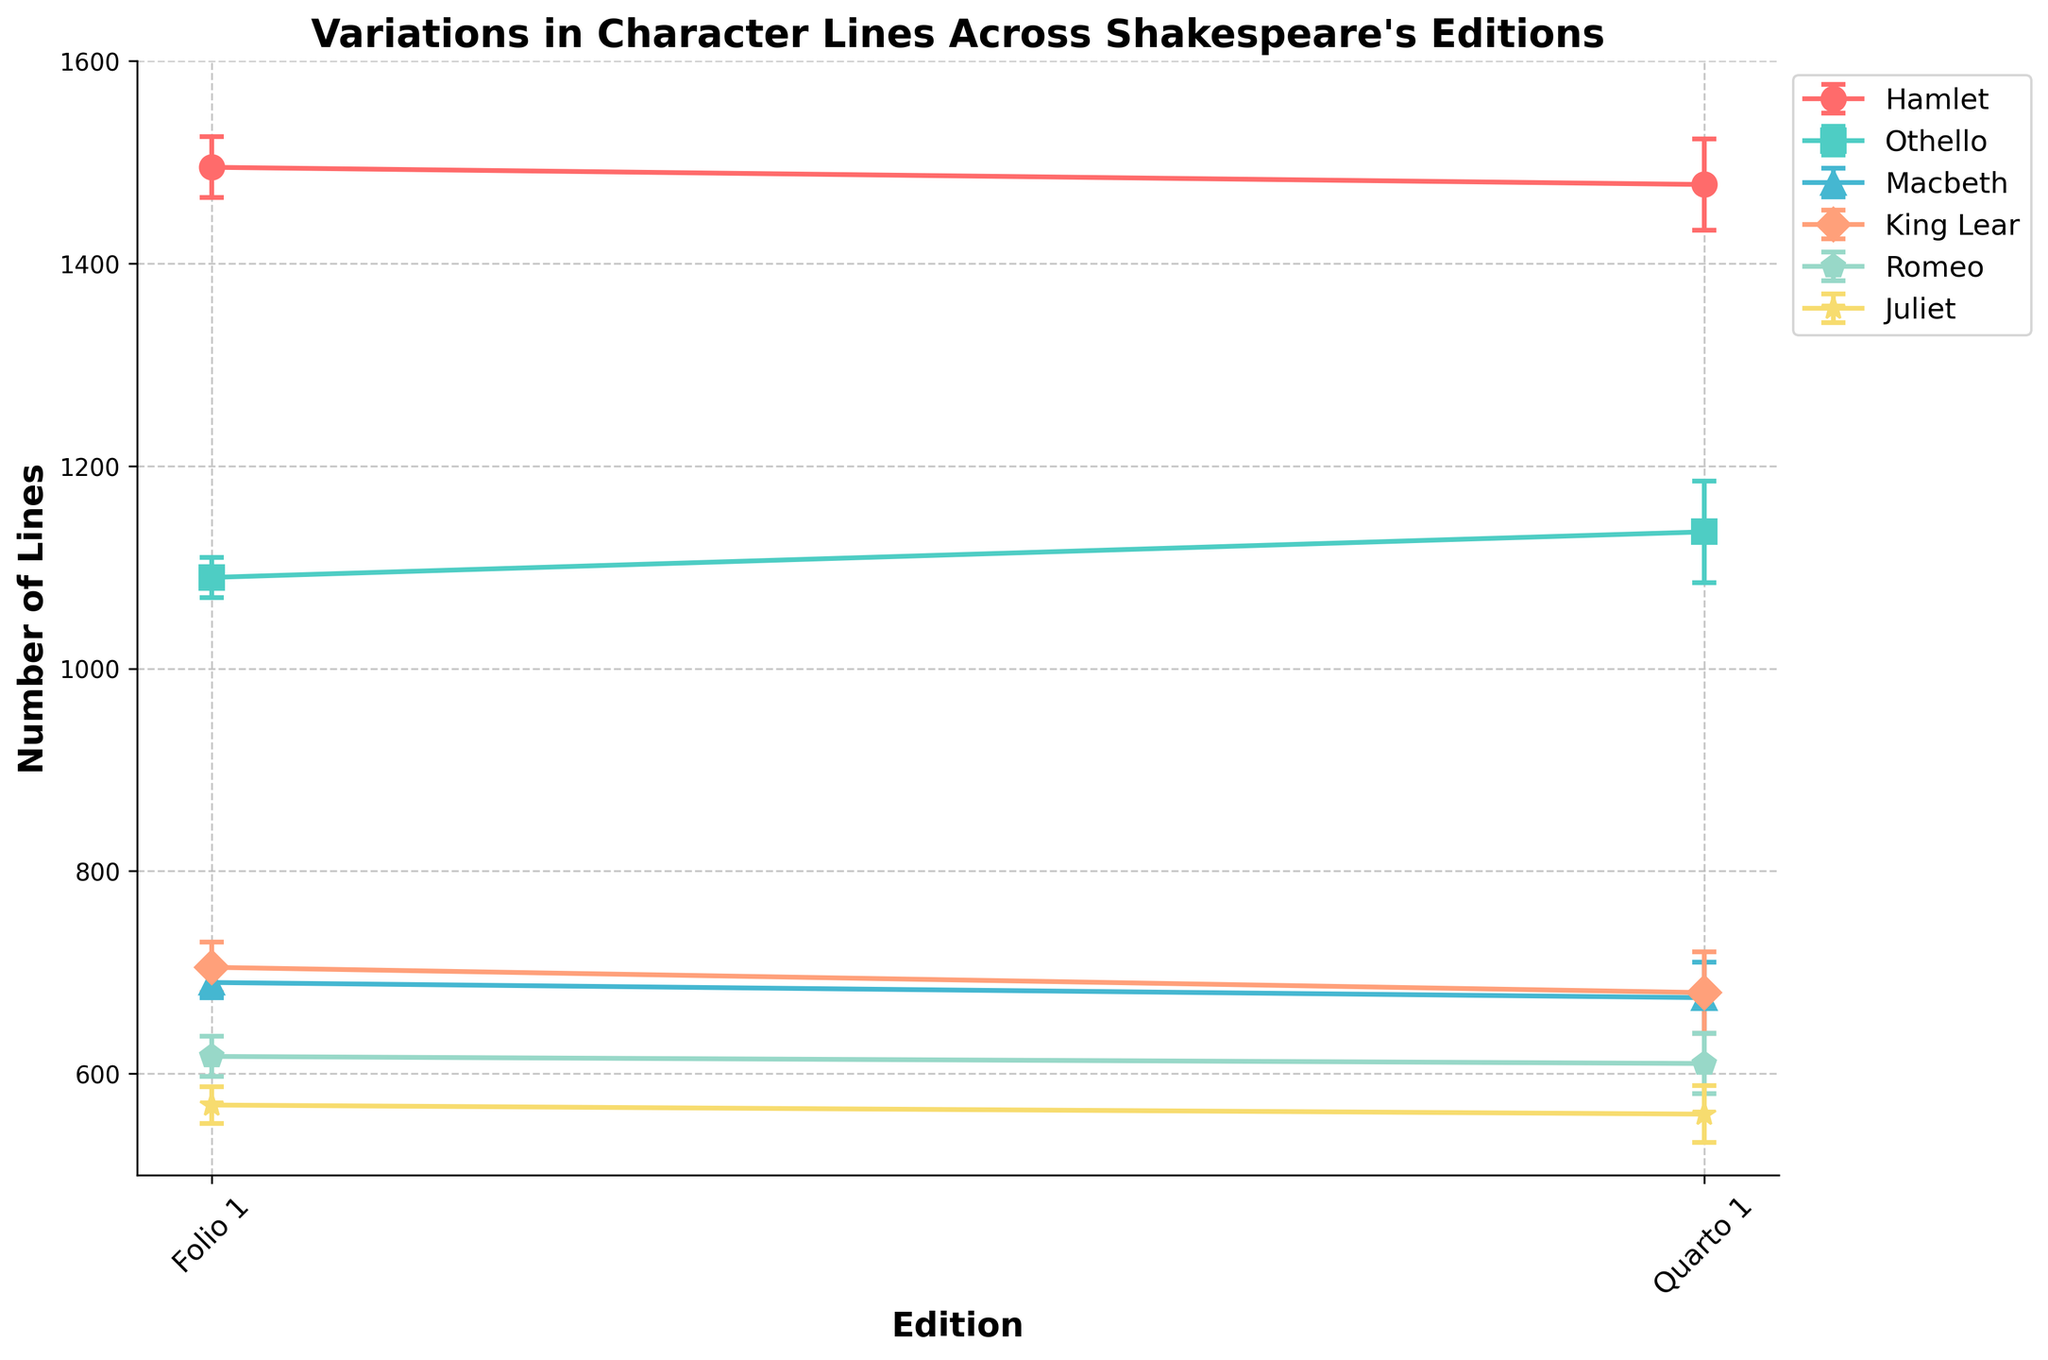what is the title of the plot? The title of the plot is displayed at the top of the figure.
Answer: "Variations in Character Lines Across Shakespeare's Editions" what are the two editions shown on the x-axis? The x-axis labels indicate the editions.
Answer: Folio 1 and Quarto 1 which character has the highest number of lines in any edition, and what is the value? By looking at the highest point on the plot, it is evident that Hamlet has the highest number of lines in the Folio 1 edition.
Answer: Hamlet, 1495 what character has the greatest difference in the number of lines between the two editions? What is the difference? To find this, calculate the absolute difference in the number of lines for each character between the two editions and compare. For Hamlet: 1495-1478=17, Othello: 1135-1090=45, Macbeth: 690-675=15, King Lear: 705-680=25, Romeo: 617-610=7, Juliet: 569-560=9. Othello has the greatest difference.
Answer: Othello, 45 which character has the largest error bar in the Quarto 1 edition? To identify this, visually inspect the length of the error bars for each character in the Quarto 1 edition.
Answer: Othello which character has the smallest difference in the number of lines between Folio 1 and Quarto 1 editions? Calculate the difference for each character: Hamlet: 17, Othello: 45, Macbeth: 15, King Lear: 25, Romeo: 7, Juliet: 9. Romeo has the smallest difference.
Answer: Romeo how many characters are analyzed in the plot? Count the number of unique labels in the legend.
Answer: 6 are there any characters who have more lines in the Quarto 1 edition compared to the Folio 1 edition? Which ones? Visually compare the data points for each character. Othello, since the Quarto 1 edition is higher than the Folio 1 edition.
Answer: Othello which character has the smallest error margin in the Folio 1 edition, and what is the value? Check the length of each error bar and read the smallest.
Answer: Macbeth, 15 is there any character whose number of lines are closer between the two editions, and has a larger error bar in one of the editions? By comparing both the differences in lines and the error bars for each character, Othello has a notable difference in lines with larger error bars.
Answer: Othello 